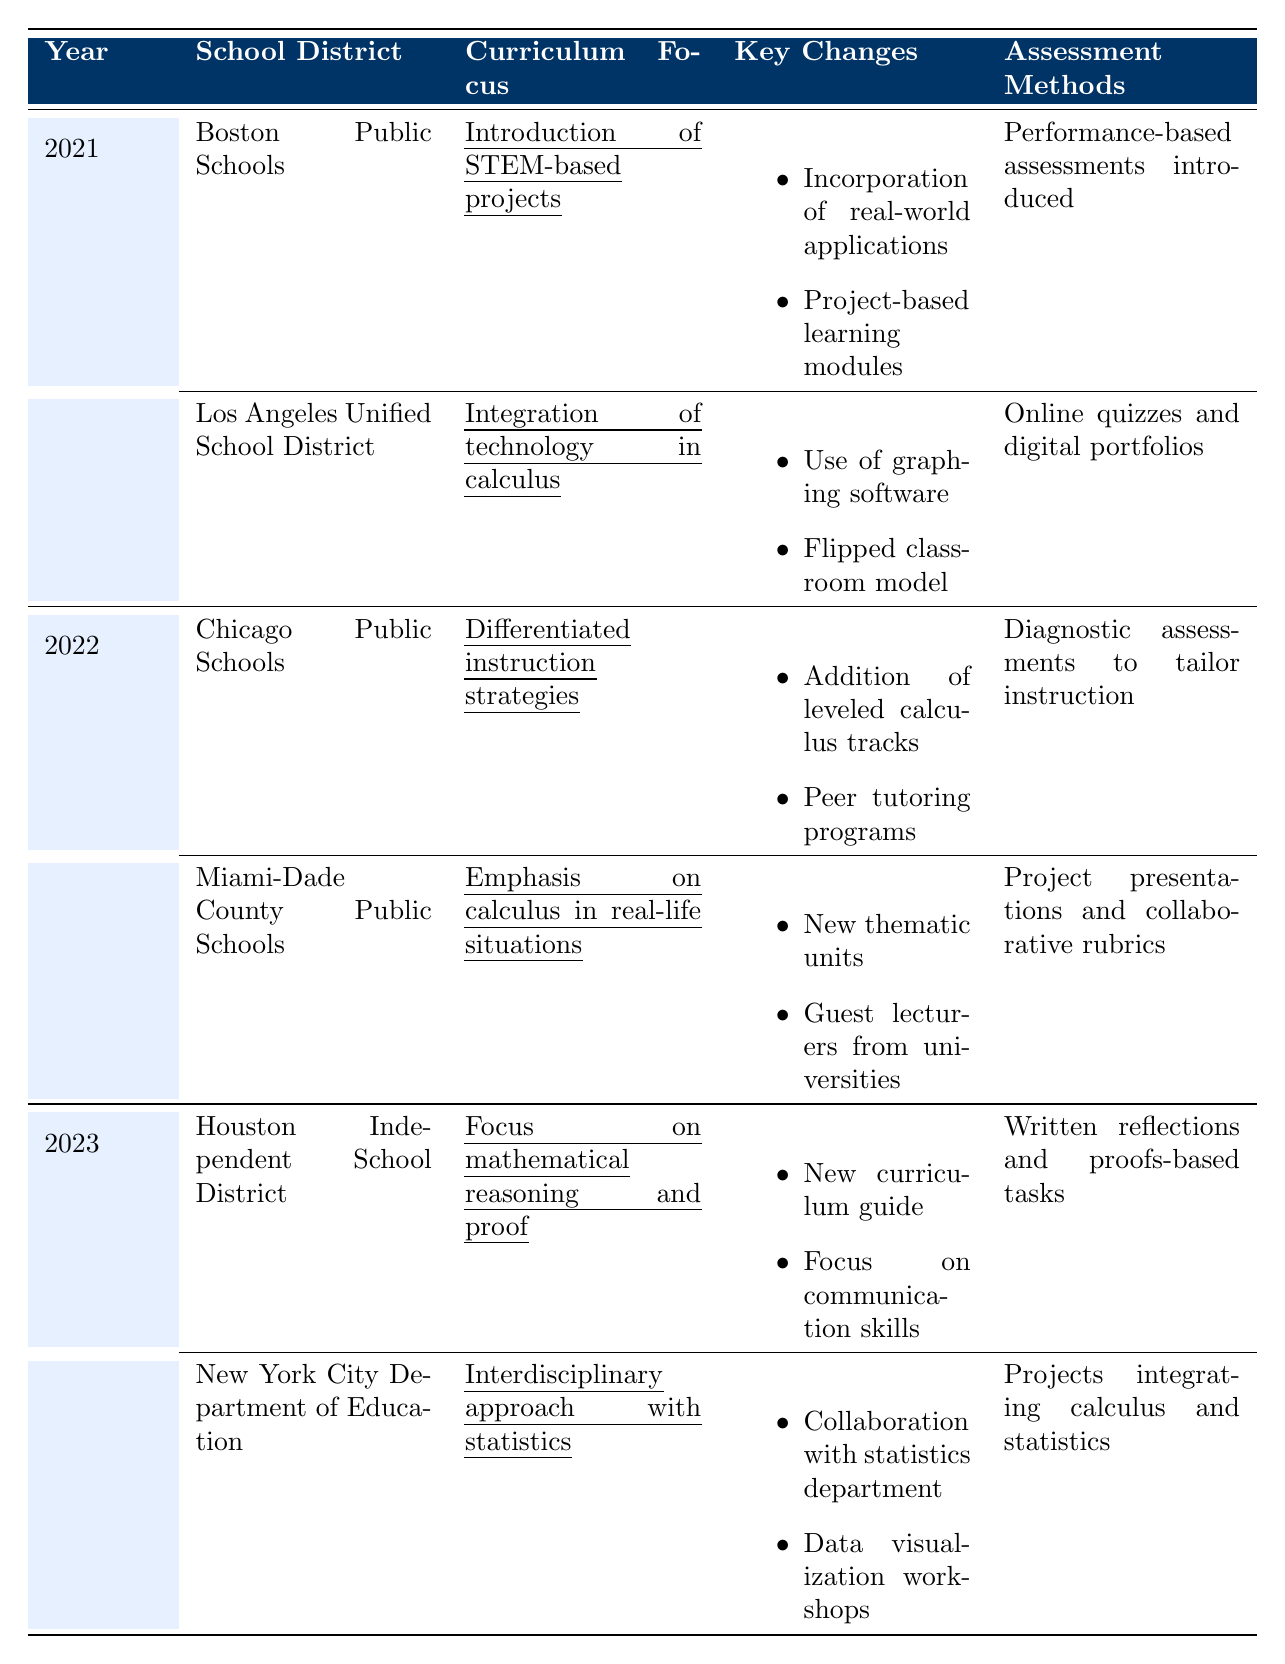What curriculum focus did Boston Public Schools adopt in 2021? The table lists the curriculum focus for Boston Public Schools in 2021 as "Introduction of STEM-based projects."
Answer: Introduction of STEM-based projects Which assessment method was used by Los Angeles Unified School District in 2021? Looking at the table, Los Angeles Unified School District utilized "Online quizzes and digital portfolios" as their assessment method in 2021.
Answer: Online quizzes and digital portfolios How many school districts implemented curriculum changes in 2022? The table shows two school districts (Chicago Public Schools and Miami-Dade County Public Schools) that made curriculum changes in 2022.
Answer: 2 What key change was common in both schools that modified their curriculum in 2022? In 2022, both Chicago Public Schools and Miami-Dade County Public Schools included peer-related initiatives, such as "Peer tutoring programs" in Chicago and "Guest lecturers from universities" in Miami.
Answer: No common key change What is the primary curriculum focus of Houston Independent School District in 2023? The table indicates that the primary focus for Houston Independent School District in 2023 is on "mathematical reasoning and proof."
Answer: Mathematical reasoning and proof How many distinct assessment methods were used across all school districts in 2021? By reviewing the assessment methods in 2021, there are two distinct ones: "Performance-based assessments" from Boston Public Schools and "Online quizzes and digital portfolios" from Los Angeles Unified School District.
Answer: 2 Which school district introduced guest lecturers as part of their curriculum changes, and in which year? The Miami-Dade County Public Schools introduced guest lecturers as part of their curriculum changes in 2022.
Answer: Miami-Dade County Public Schools, 2022 What is the focus of the New York City Department of Education's curriculum in 2023, and how does it relate to other subjects? The focus is an "interdisciplinary approach with statistics," emphasizing the integration of calculus and statistics through projects.
Answer: Interdisciplinary approach with statistics In which year was the focus on "differentiated instruction strategies" introduced, and what was a key change associated with it? The focus on "differentiated instruction strategies" was introduced in 2022, and a key change associated with it was the "Addition of leveled calculus tracks for students."
Answer: 2022, Addition of leveled calculus tracks for students Explain the relationship between assessment methods and curriculum focus for the Houston Independent School District in 2023. The curriculum focus for Houston in 2023 is on mathematical reasoning and proof, and the assessment methods chosen are "Written reflections and proofs-based tasks," which align with the curriculum by emphasizing reasoning and proof techniques.
Answer: The focus on reasoning matches the proofs-based assessment Count the total number of changes implemented in 2023 compared to 2021. In 2021, there were four key changes mentioned (two districts), and in 2023 there were four key changes also (two districts). Since both years have the same number of changes, the total in each year is compared and is equal.
Answer: 0 (same number of changes) 